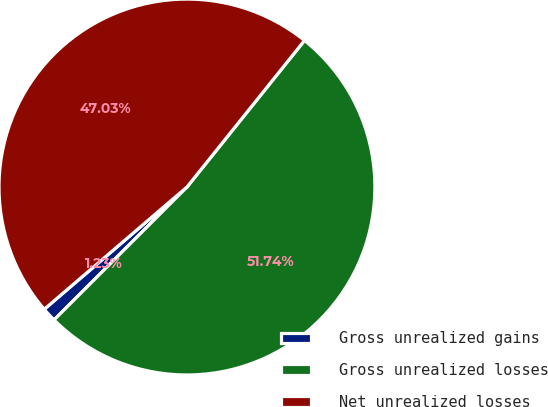Convert chart to OTSL. <chart><loc_0><loc_0><loc_500><loc_500><pie_chart><fcel>Gross unrealized gains<fcel>Gross unrealized losses<fcel>Net unrealized losses<nl><fcel>1.23%<fcel>51.74%<fcel>47.03%<nl></chart> 